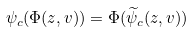<formula> <loc_0><loc_0><loc_500><loc_500>\psi _ { c } ( \Phi ( z , v ) ) = \Phi ( \widetilde { \psi } _ { c } ( z , v ) )</formula> 